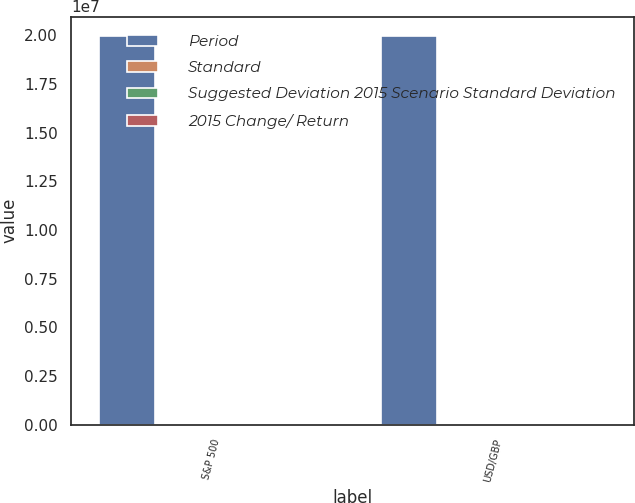Convert chart to OTSL. <chart><loc_0><loc_0><loc_500><loc_500><stacked_bar_chart><ecel><fcel>S&P 500<fcel>USD/GBP<nl><fcel>Period<fcel>1.9952e+07<fcel>1.9952e+07<nl><fcel>Standard<fcel>0.18<fcel>0.09<nl><fcel>Suggested Deviation 2015 Scenario Standard Deviation<fcel>0.2<fcel>0.1<nl><fcel>2015 Change/ Return<fcel>1.09<fcel>1.06<nl></chart> 